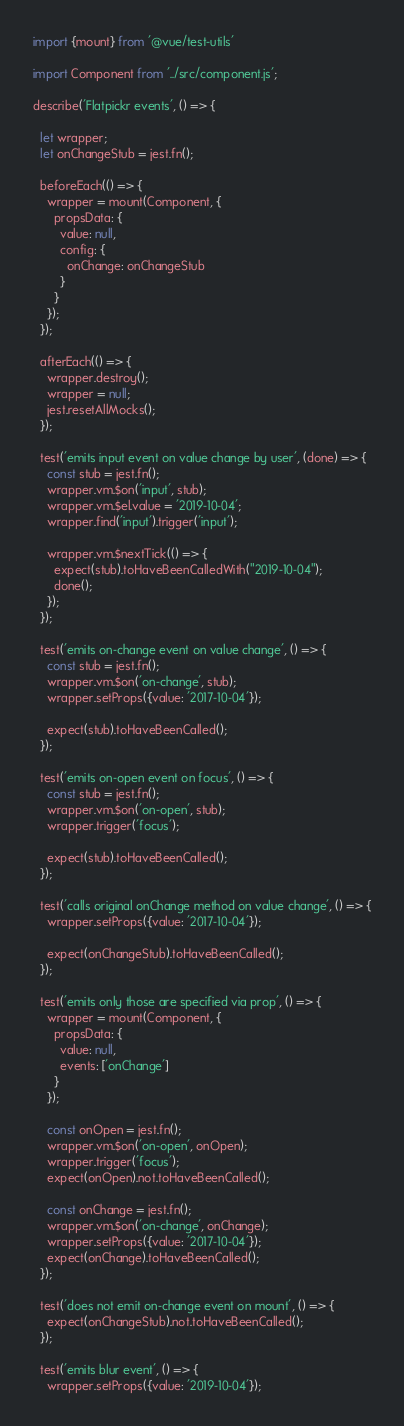Convert code to text. <code><loc_0><loc_0><loc_500><loc_500><_JavaScript_>import {mount} from '@vue/test-utils'

import Component from '../src/component.js';

describe('Flatpickr events', () => {

  let wrapper;
  let onChangeStub = jest.fn();

  beforeEach(() => {
    wrapper = mount(Component, {
      propsData: {
        value: null,
        config: {
          onChange: onChangeStub
        }
      }
    });
  });

  afterEach(() => {
    wrapper.destroy();
    wrapper = null;
    jest.resetAllMocks();
  });

  test('emits input event on value change by user', (done) => {
    const stub = jest.fn();
    wrapper.vm.$on('input', stub);
    wrapper.vm.$el.value = '2019-10-04';
    wrapper.find('input').trigger('input');

    wrapper.vm.$nextTick(() => {
      expect(stub).toHaveBeenCalledWith("2019-10-04");
      done();
    });
  });

  test('emits on-change event on value change', () => {
    const stub = jest.fn();
    wrapper.vm.$on('on-change', stub);
    wrapper.setProps({value: '2017-10-04'});

    expect(stub).toHaveBeenCalled();
  });

  test('emits on-open event on focus', () => {
    const stub = jest.fn();
    wrapper.vm.$on('on-open', stub);
    wrapper.trigger('focus');

    expect(stub).toHaveBeenCalled();
  });

  test('calls original onChange method on value change', () => {
    wrapper.setProps({value: '2017-10-04'});

    expect(onChangeStub).toHaveBeenCalled();
  });

  test('emits only those are specified via prop', () => {
    wrapper = mount(Component, {
      propsData: {
        value: null,
        events: ['onChange']
      }
    });

    const onOpen = jest.fn();
    wrapper.vm.$on('on-open', onOpen);
    wrapper.trigger('focus');
    expect(onOpen).not.toHaveBeenCalled();

    const onChange = jest.fn();
    wrapper.vm.$on('on-change', onChange);
    wrapper.setProps({value: '2017-10-04'});
    expect(onChange).toHaveBeenCalled();
  });

  test('does not emit on-change event on mount', () => {
    expect(onChangeStub).not.toHaveBeenCalled();
  });

  test('emits blur event', () => {
    wrapper.setProps({value: '2019-10-04'});</code> 